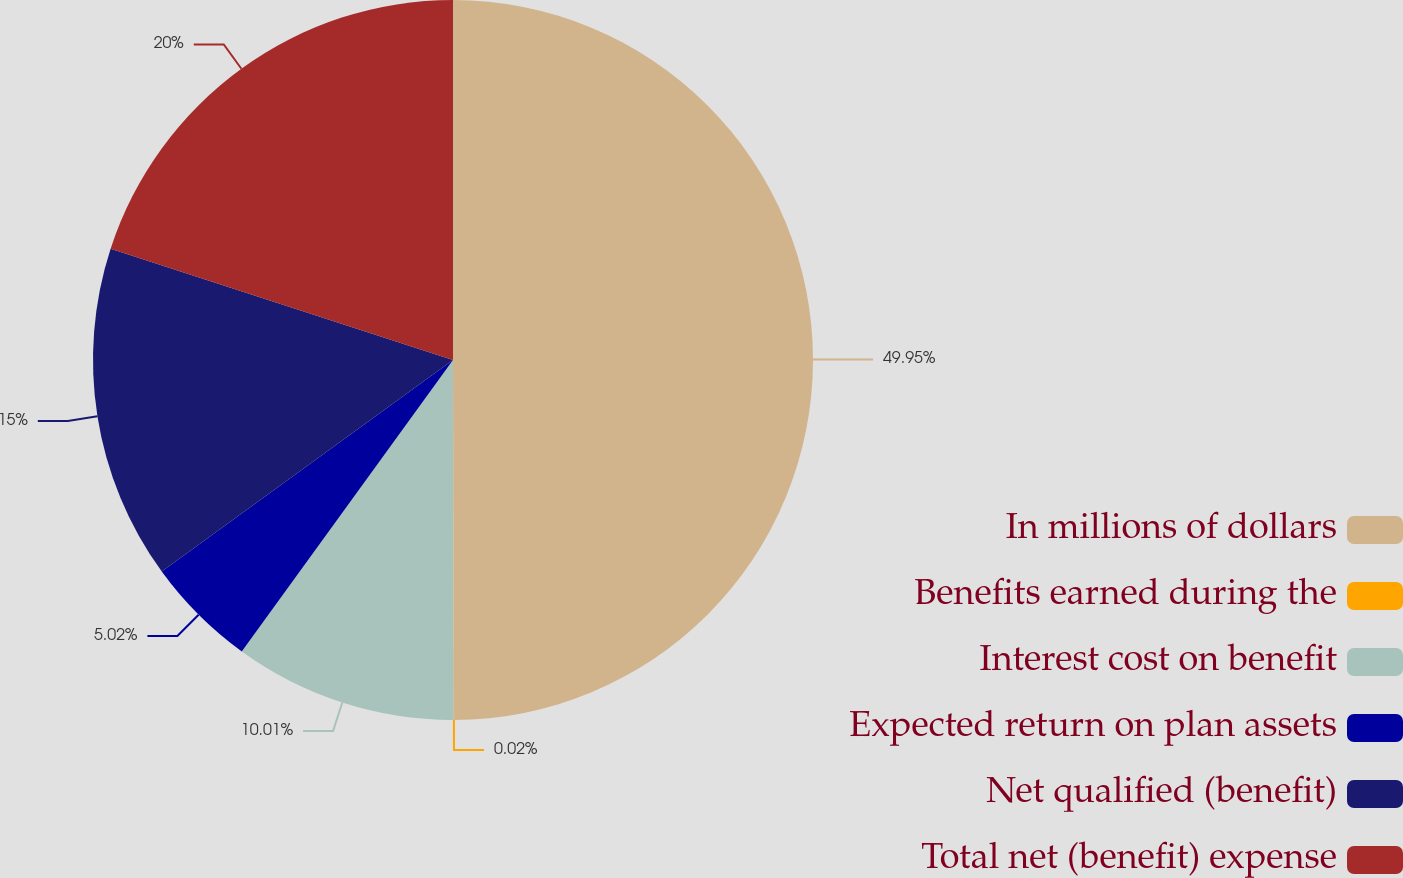<chart> <loc_0><loc_0><loc_500><loc_500><pie_chart><fcel>In millions of dollars<fcel>Benefits earned during the<fcel>Interest cost on benefit<fcel>Expected return on plan assets<fcel>Net qualified (benefit)<fcel>Total net (benefit) expense<nl><fcel>49.95%<fcel>0.02%<fcel>10.01%<fcel>5.02%<fcel>15.0%<fcel>20.0%<nl></chart> 